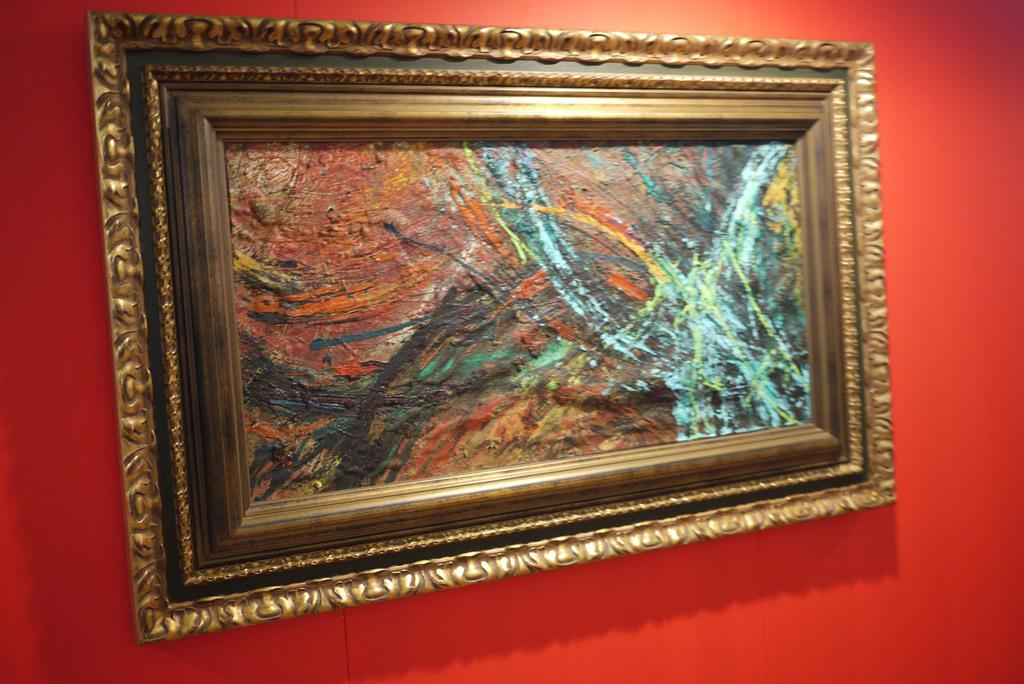What color is the wall that is visible in the image? The wall in the image is red. What object can be seen on the wall in the image? There is a photo frame on the wall in the image. What type of dock can be seen in the image? There is no dock present in the image. 